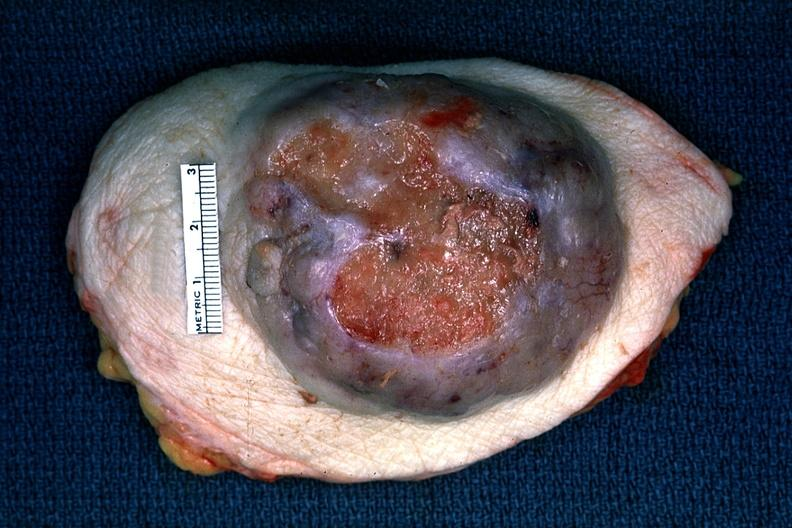s adenocarcinoma present?
Answer the question using a single word or phrase. Yes 